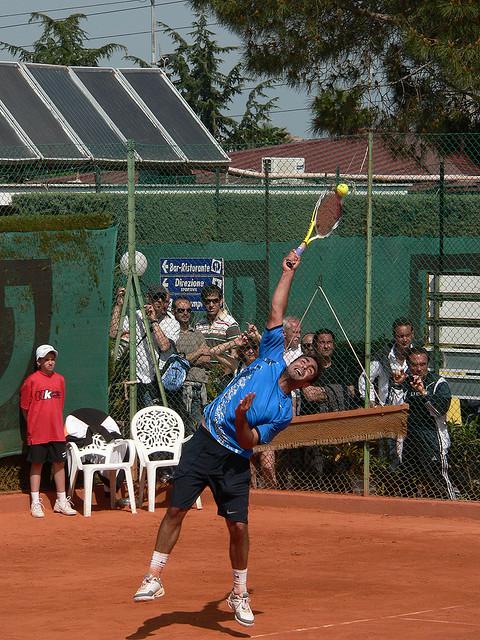What color are the chairs?
Short answer required. White. Is this player wearing sunglasses?
Concise answer only. No. What is this person holding?
Write a very short answer. Tennis racket. 